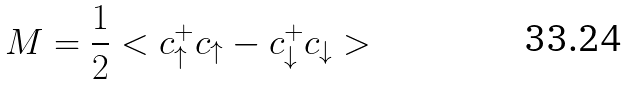Convert formula to latex. <formula><loc_0><loc_0><loc_500><loc_500>M = \frac { 1 } { 2 } < c ^ { + } _ { \uparrow } c _ { \uparrow } - c ^ { + } _ { \downarrow } c _ { \downarrow } ></formula> 